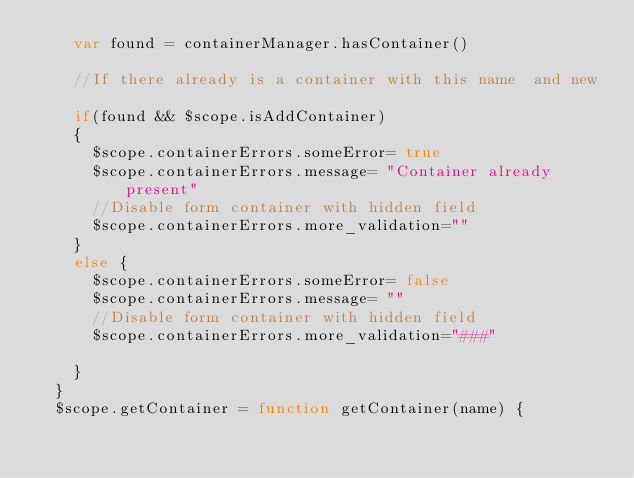<code> <loc_0><loc_0><loc_500><loc_500><_JavaScript_>    var found = containerManager.hasContainer()

    //If there already is a container with this name  and new

    if(found && $scope.isAddContainer)
    {
      $scope.containerErrors.someError= true
      $scope.containerErrors.message= "Container already present"
      //Disable form container with hidden field
      $scope.containerErrors.more_validation=""
    }
    else {
      $scope.containerErrors.someError= false
      $scope.containerErrors.message= ""
      //Disable form container with hidden field
      $scope.containerErrors.more_validation="###"

    }
  }
  $scope.getContainer = function getContainer(name) {</code> 